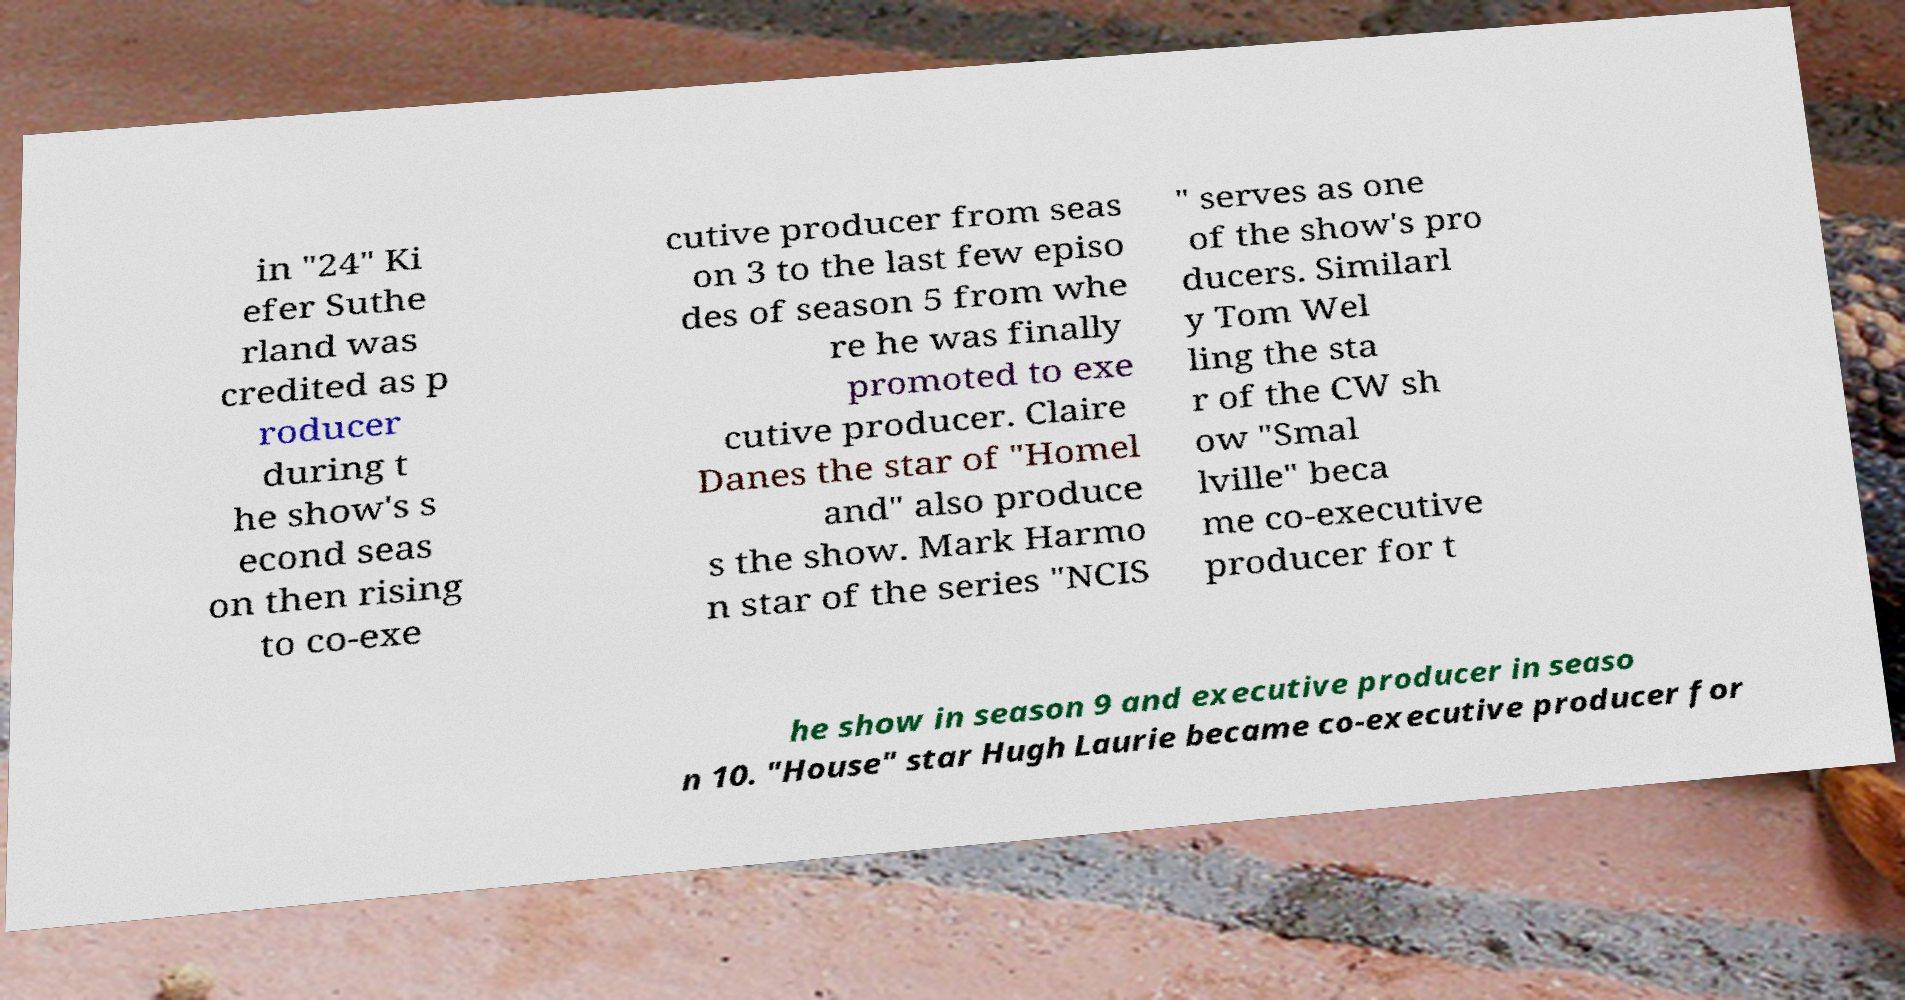Please identify and transcribe the text found in this image. in "24" Ki efer Suthe rland was credited as p roducer during t he show's s econd seas on then rising to co-exe cutive producer from seas on 3 to the last few episo des of season 5 from whe re he was finally promoted to exe cutive producer. Claire Danes the star of "Homel and" also produce s the show. Mark Harmo n star of the series "NCIS " serves as one of the show's pro ducers. Similarl y Tom Wel ling the sta r of the CW sh ow "Smal lville" beca me co-executive producer for t he show in season 9 and executive producer in seaso n 10. "House" star Hugh Laurie became co-executive producer for 